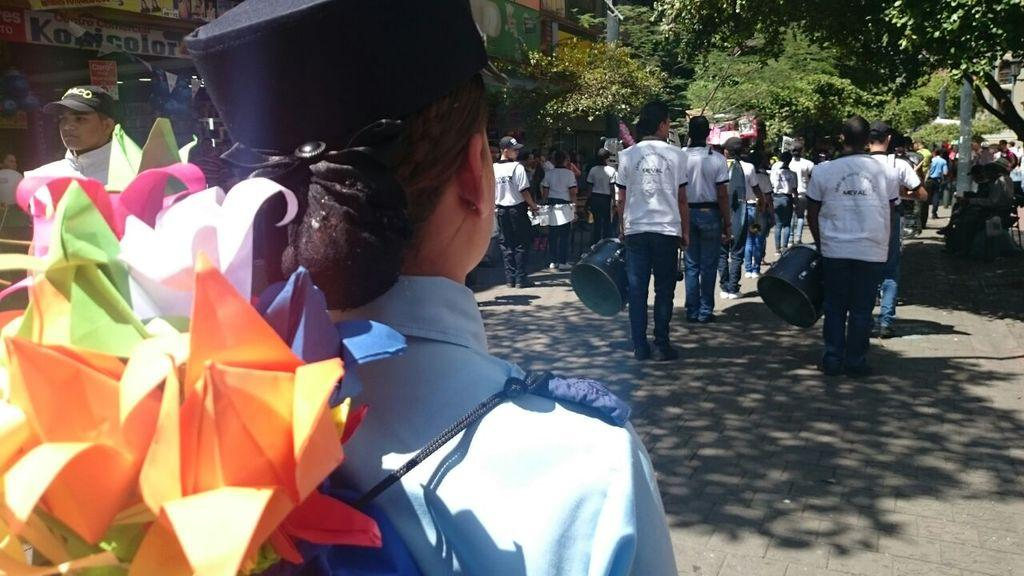How many people are present in the image? There are people in the image, but the exact number cannot be determined from the provided facts. What type of surface can be seen in the image? There is a road in the image. What are the boards used for in the image? The purpose of the boards in the image cannot be determined from the provided facts. What type of crafts can be seen in the image? There are paper crafts in the image. What are the poles used for in the image? The purpose of the poles in the image cannot be determined from the provided facts. What type of vegetation is present in the image? There are trees in the image. What other objects can be seen in the image? There are other objects in the image, but their specific nature cannot be determined from the provided facts. What type of chain is hanging from the sign in the image? There is no chain or sign present in the image. What type of body is visible in the image? There is no body present in the image. 